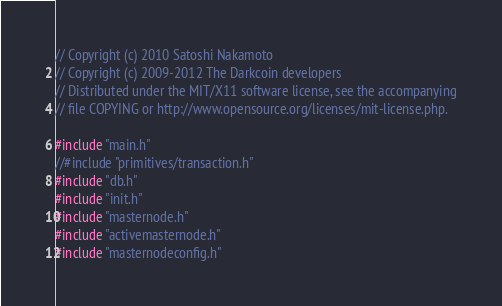Convert code to text. <code><loc_0><loc_0><loc_500><loc_500><_C++_>// Copyright (c) 2010 Satoshi Nakamoto
// Copyright (c) 2009-2012 The Darkcoin developers
// Distributed under the MIT/X11 software license, see the accompanying
// file COPYING or http://www.opensource.org/licenses/mit-license.php.

#include "main.h"
//#include "primitives/transaction.h"
#include "db.h"
#include "init.h"
#include "masternode.h"
#include "activemasternode.h"
#include "masternodeconfig.h"</code> 